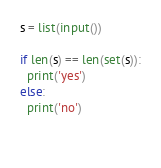<code> <loc_0><loc_0><loc_500><loc_500><_Python_>s = list(input())

if len(s) == len(set(s)):
  print('yes')
else:
  print('no')
  
  </code> 